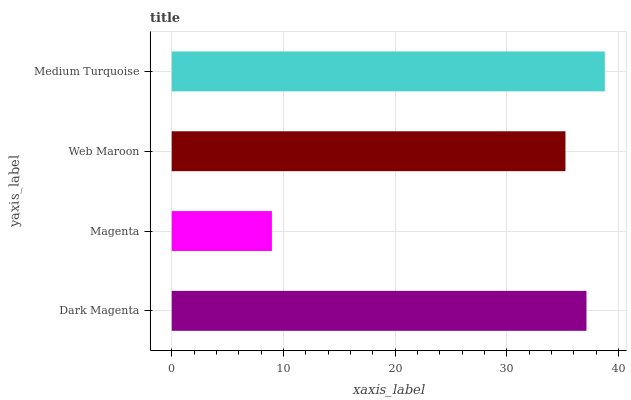Is Magenta the minimum?
Answer yes or no. Yes. Is Medium Turquoise the maximum?
Answer yes or no. Yes. Is Web Maroon the minimum?
Answer yes or no. No. Is Web Maroon the maximum?
Answer yes or no. No. Is Web Maroon greater than Magenta?
Answer yes or no. Yes. Is Magenta less than Web Maroon?
Answer yes or no. Yes. Is Magenta greater than Web Maroon?
Answer yes or no. No. Is Web Maroon less than Magenta?
Answer yes or no. No. Is Dark Magenta the high median?
Answer yes or no. Yes. Is Web Maroon the low median?
Answer yes or no. Yes. Is Web Maroon the high median?
Answer yes or no. No. Is Magenta the low median?
Answer yes or no. No. 